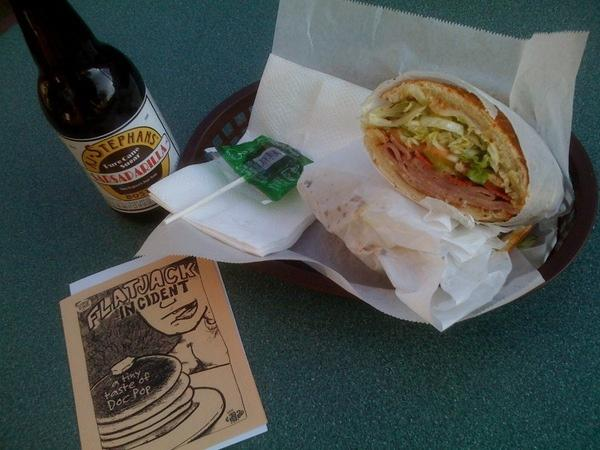This beverage tastes similar to what other beverage?

Choices:
A) sprite
B) ginger ale
C) sorrel drink
D) root beer root beer 